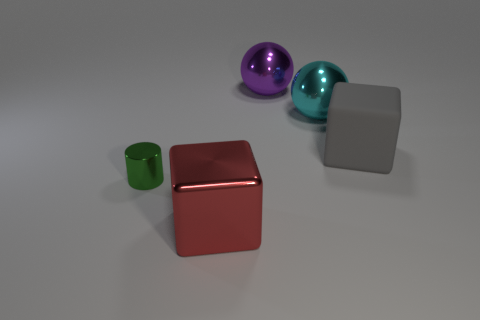There is a shiny thing in front of the tiny green shiny cylinder to the left of the large object in front of the large gray rubber object; what size is it?
Make the answer very short. Large. There is a large cube behind the big metallic thing in front of the large matte cube; what is it made of?
Offer a very short reply. Rubber. Are there more green shiny things that are to the left of the cylinder than gray shiny spheres?
Provide a short and direct response. No. How many other objects are there of the same size as the red metallic cube?
Your response must be concise. 3. Is the shiny cube the same color as the metal cylinder?
Make the answer very short. No. What color is the metal thing to the left of the big block that is in front of the cube right of the big purple thing?
Keep it short and to the point. Green. There is a big object in front of the big block behind the green object; what number of shiny blocks are behind it?
Your answer should be very brief. 0. Is there any other thing that is the same color as the small shiny cylinder?
Keep it short and to the point. No. Is the size of the metallic ball on the left side of the cyan metal ball the same as the gray object?
Your answer should be compact. Yes. How many cyan balls are on the right side of the shiny object on the left side of the red metallic object?
Offer a very short reply. 1. 